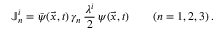Convert formula to latex. <formula><loc_0><loc_0><loc_500><loc_500>\mathbb { J } _ { n } ^ { i } = \bar { \psi } ( \vec { x } , t ) \, \gamma _ { n } \, { \frac { \lambda ^ { i } } { 2 } } \, \psi ( \vec { x } , t ) \quad ( n = 1 , 2 , 3 ) \, .</formula> 